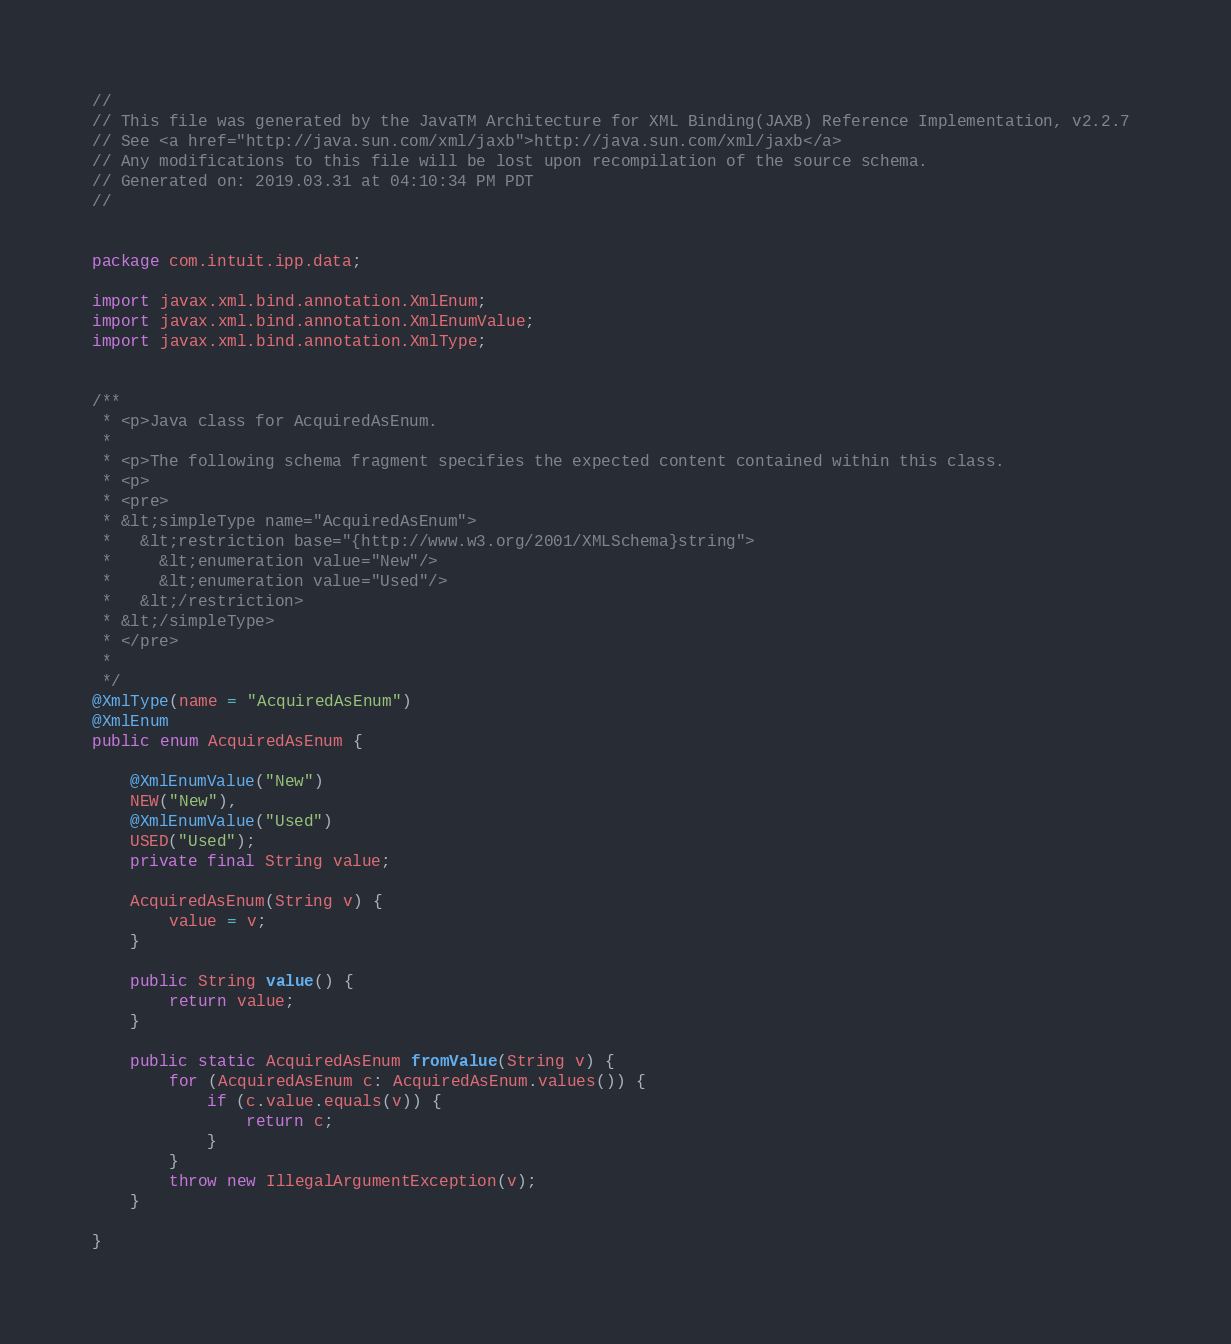Convert code to text. <code><loc_0><loc_0><loc_500><loc_500><_Java_>//
// This file was generated by the JavaTM Architecture for XML Binding(JAXB) Reference Implementation, v2.2.7 
// See <a href="http://java.sun.com/xml/jaxb">http://java.sun.com/xml/jaxb</a> 
// Any modifications to this file will be lost upon recompilation of the source schema. 
// Generated on: 2019.03.31 at 04:10:34 PM PDT 
//


package com.intuit.ipp.data;

import javax.xml.bind.annotation.XmlEnum;
import javax.xml.bind.annotation.XmlEnumValue;
import javax.xml.bind.annotation.XmlType;


/**
 * <p>Java class for AcquiredAsEnum.
 * 
 * <p>The following schema fragment specifies the expected content contained within this class.
 * <p>
 * <pre>
 * &lt;simpleType name="AcquiredAsEnum">
 *   &lt;restriction base="{http://www.w3.org/2001/XMLSchema}string">
 *     &lt;enumeration value="New"/>
 *     &lt;enumeration value="Used"/>
 *   &lt;/restriction>
 * &lt;/simpleType>
 * </pre>
 * 
 */
@XmlType(name = "AcquiredAsEnum")
@XmlEnum
public enum AcquiredAsEnum {

    @XmlEnumValue("New")
    NEW("New"),
    @XmlEnumValue("Used")
    USED("Used");
    private final String value;

    AcquiredAsEnum(String v) {
        value = v;
    }

    public String value() {
        return value;
    }

    public static AcquiredAsEnum fromValue(String v) {
        for (AcquiredAsEnum c: AcquiredAsEnum.values()) {
            if (c.value.equals(v)) {
                return c;
            }
        }
        throw new IllegalArgumentException(v);
    }

}
</code> 